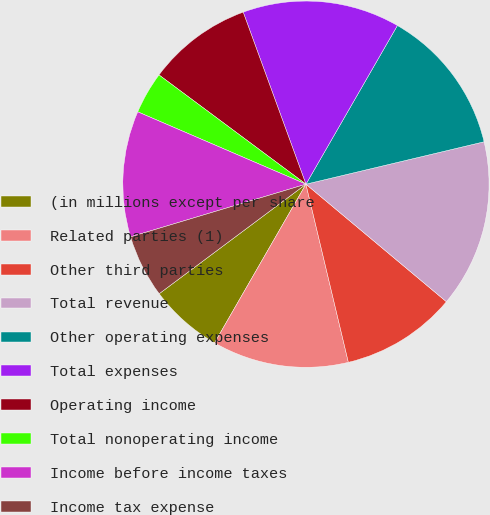<chart> <loc_0><loc_0><loc_500><loc_500><pie_chart><fcel>(in millions except per share<fcel>Related parties (1)<fcel>Other third parties<fcel>Total revenue<fcel>Other operating expenses<fcel>Total expenses<fcel>Operating income<fcel>Total nonoperating income<fcel>Income before income taxes<fcel>Income tax expense<nl><fcel>6.48%<fcel>12.04%<fcel>10.19%<fcel>14.81%<fcel>12.96%<fcel>13.89%<fcel>9.26%<fcel>3.71%<fcel>11.11%<fcel>5.56%<nl></chart> 